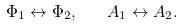<formula> <loc_0><loc_0><loc_500><loc_500>\Phi _ { 1 } \leftrightarrow \Phi _ { 2 } , \quad A _ { 1 } \leftrightarrow A _ { 2 } .</formula> 